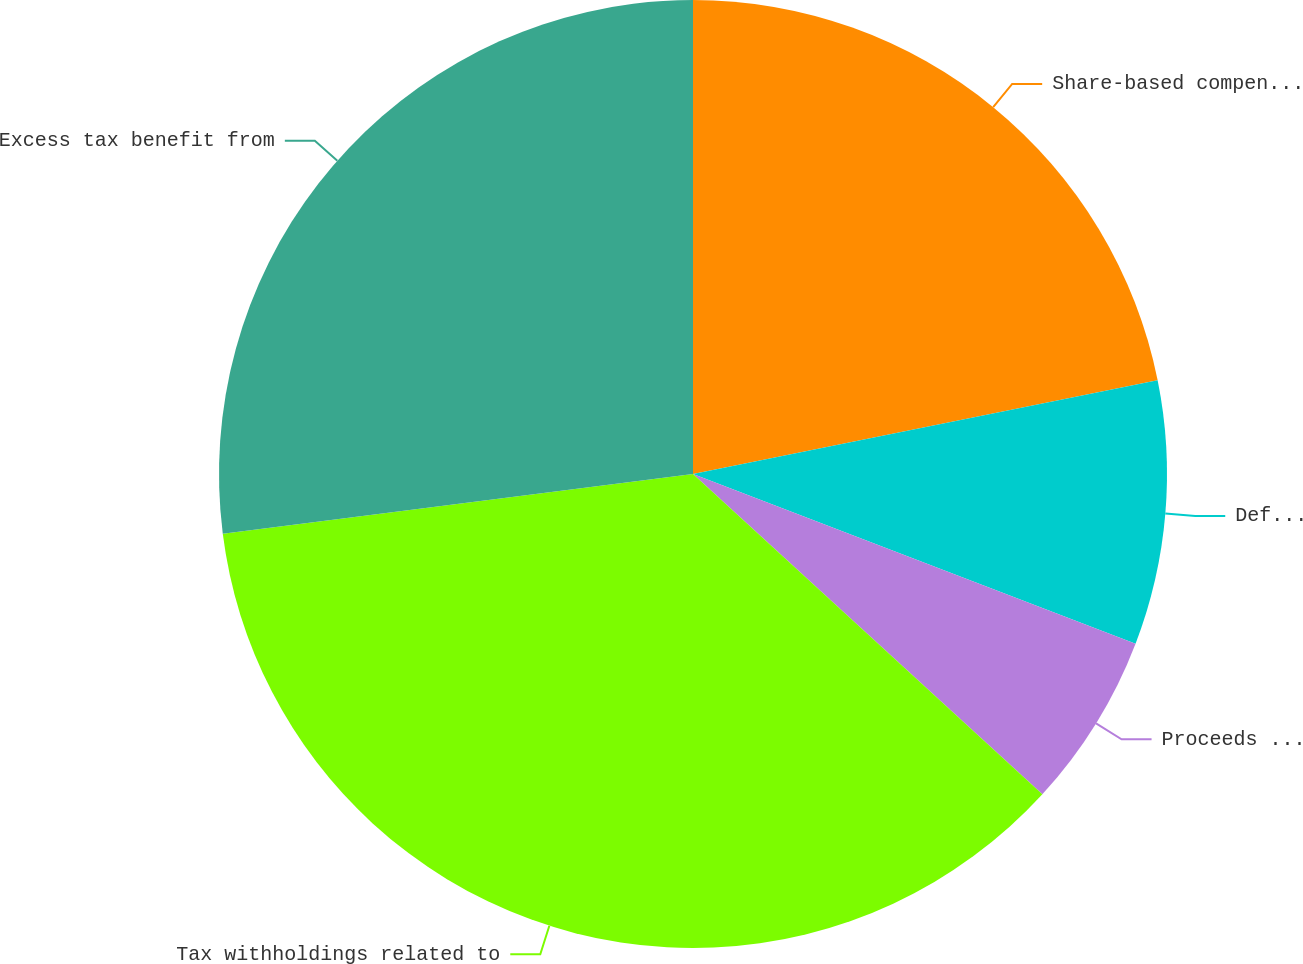Convert chart to OTSL. <chart><loc_0><loc_0><loc_500><loc_500><pie_chart><fcel>Share-based compensation<fcel>Deferred income tax benefit<fcel>Proceeds from the issuance of<fcel>Tax withholdings related to<fcel>Excess tax benefit from<nl><fcel>21.83%<fcel>9.0%<fcel>5.98%<fcel>36.18%<fcel>27.01%<nl></chart> 